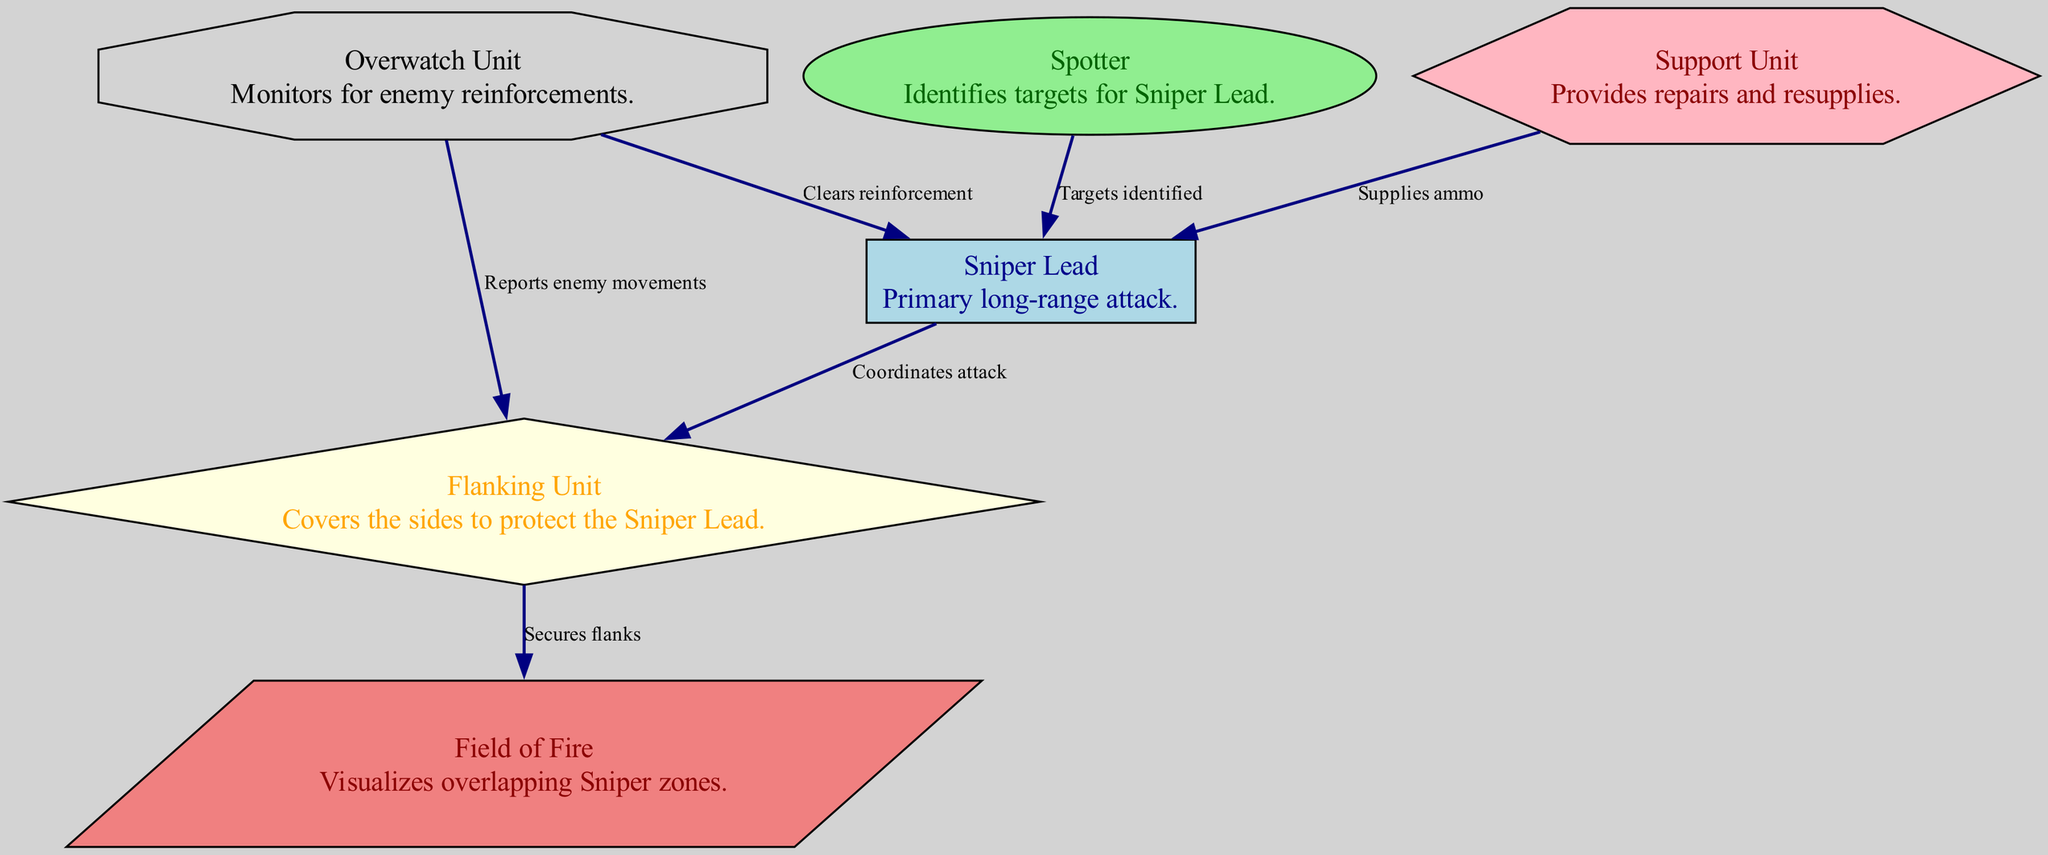What is the main role of the Sniper Lead? The Sniper Lead is primarily responsible for long-range attacks as indicated in the diagram.
Answer: Primary long-range attack How many units are there in total? The diagram includes 5 units (Sniper Lead, Spotter, Flanking Unit, Support Unit, Overwatch Unit).
Answer: 5 units Which unit identifies targets for the Sniper Lead? The Spotter unit is specifically tasked with identifying targets for the Sniper Lead according to the directed edge in the diagram.
Answer: Spotter What do the Flanking Unit and Overwatch Unit collaborate on? The Flanking Unit secures flanks while the Overwatch Unit reports enemy movements; they coordinate their efforts for protection and monitoring.
Answer: Report enemy movements How does the Support Unit assist the Sniper Lead? The Support Unit provides ammo and supplies directly to the Sniper Lead as shown by the edge connecting them.
Answer: Supplies ammo How many connections does the Overwatch Unit have in the diagram? The Overwatch Unit has 2 connections: one to the Flanking Unit and one to the Sniper Lead.
Answer: 2 connections Which unit visualizes overlapping sniper zones? The Field of Fire unit is responsible for visualizing the overlapping sniper zones for effective targeting.
Answer: Field of Fire What is the purpose of the edge from Flanking Unit to Field of Fire? The edge indicates that the Flanking Unit secures the flanks, which helps reinforce the Field of Fire, a designated area of overlap among snipers.
Answer: Secures flanks What action does the Sniper Lead take after receiving targets from the Spotter? The Sniper Lead coordinates an attack to engage the targets identified by the Spotter.
Answer: Coordinates attack 